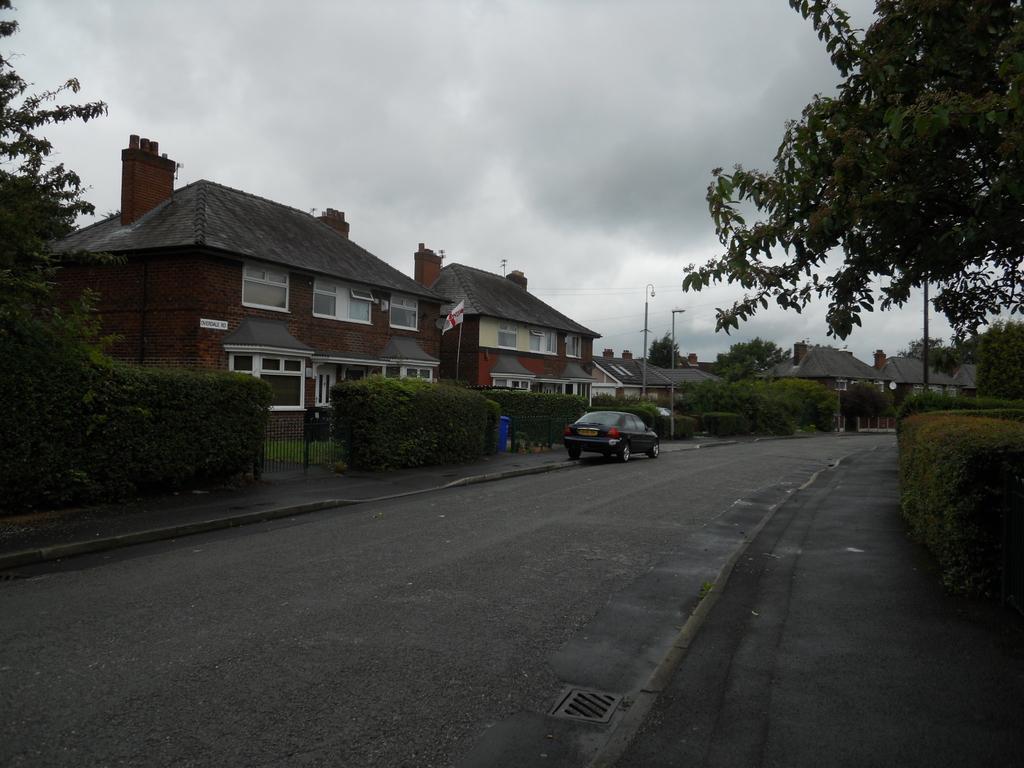In one or two sentences, can you explain what this image depicts? In this picture I can see the building, street lights, poles, trees, plants and grass. In the center there is a car which is parked near to the dustbin. Beside that I can see the flag. On the left there is a gate. At the top I can see the sky and clouds. 